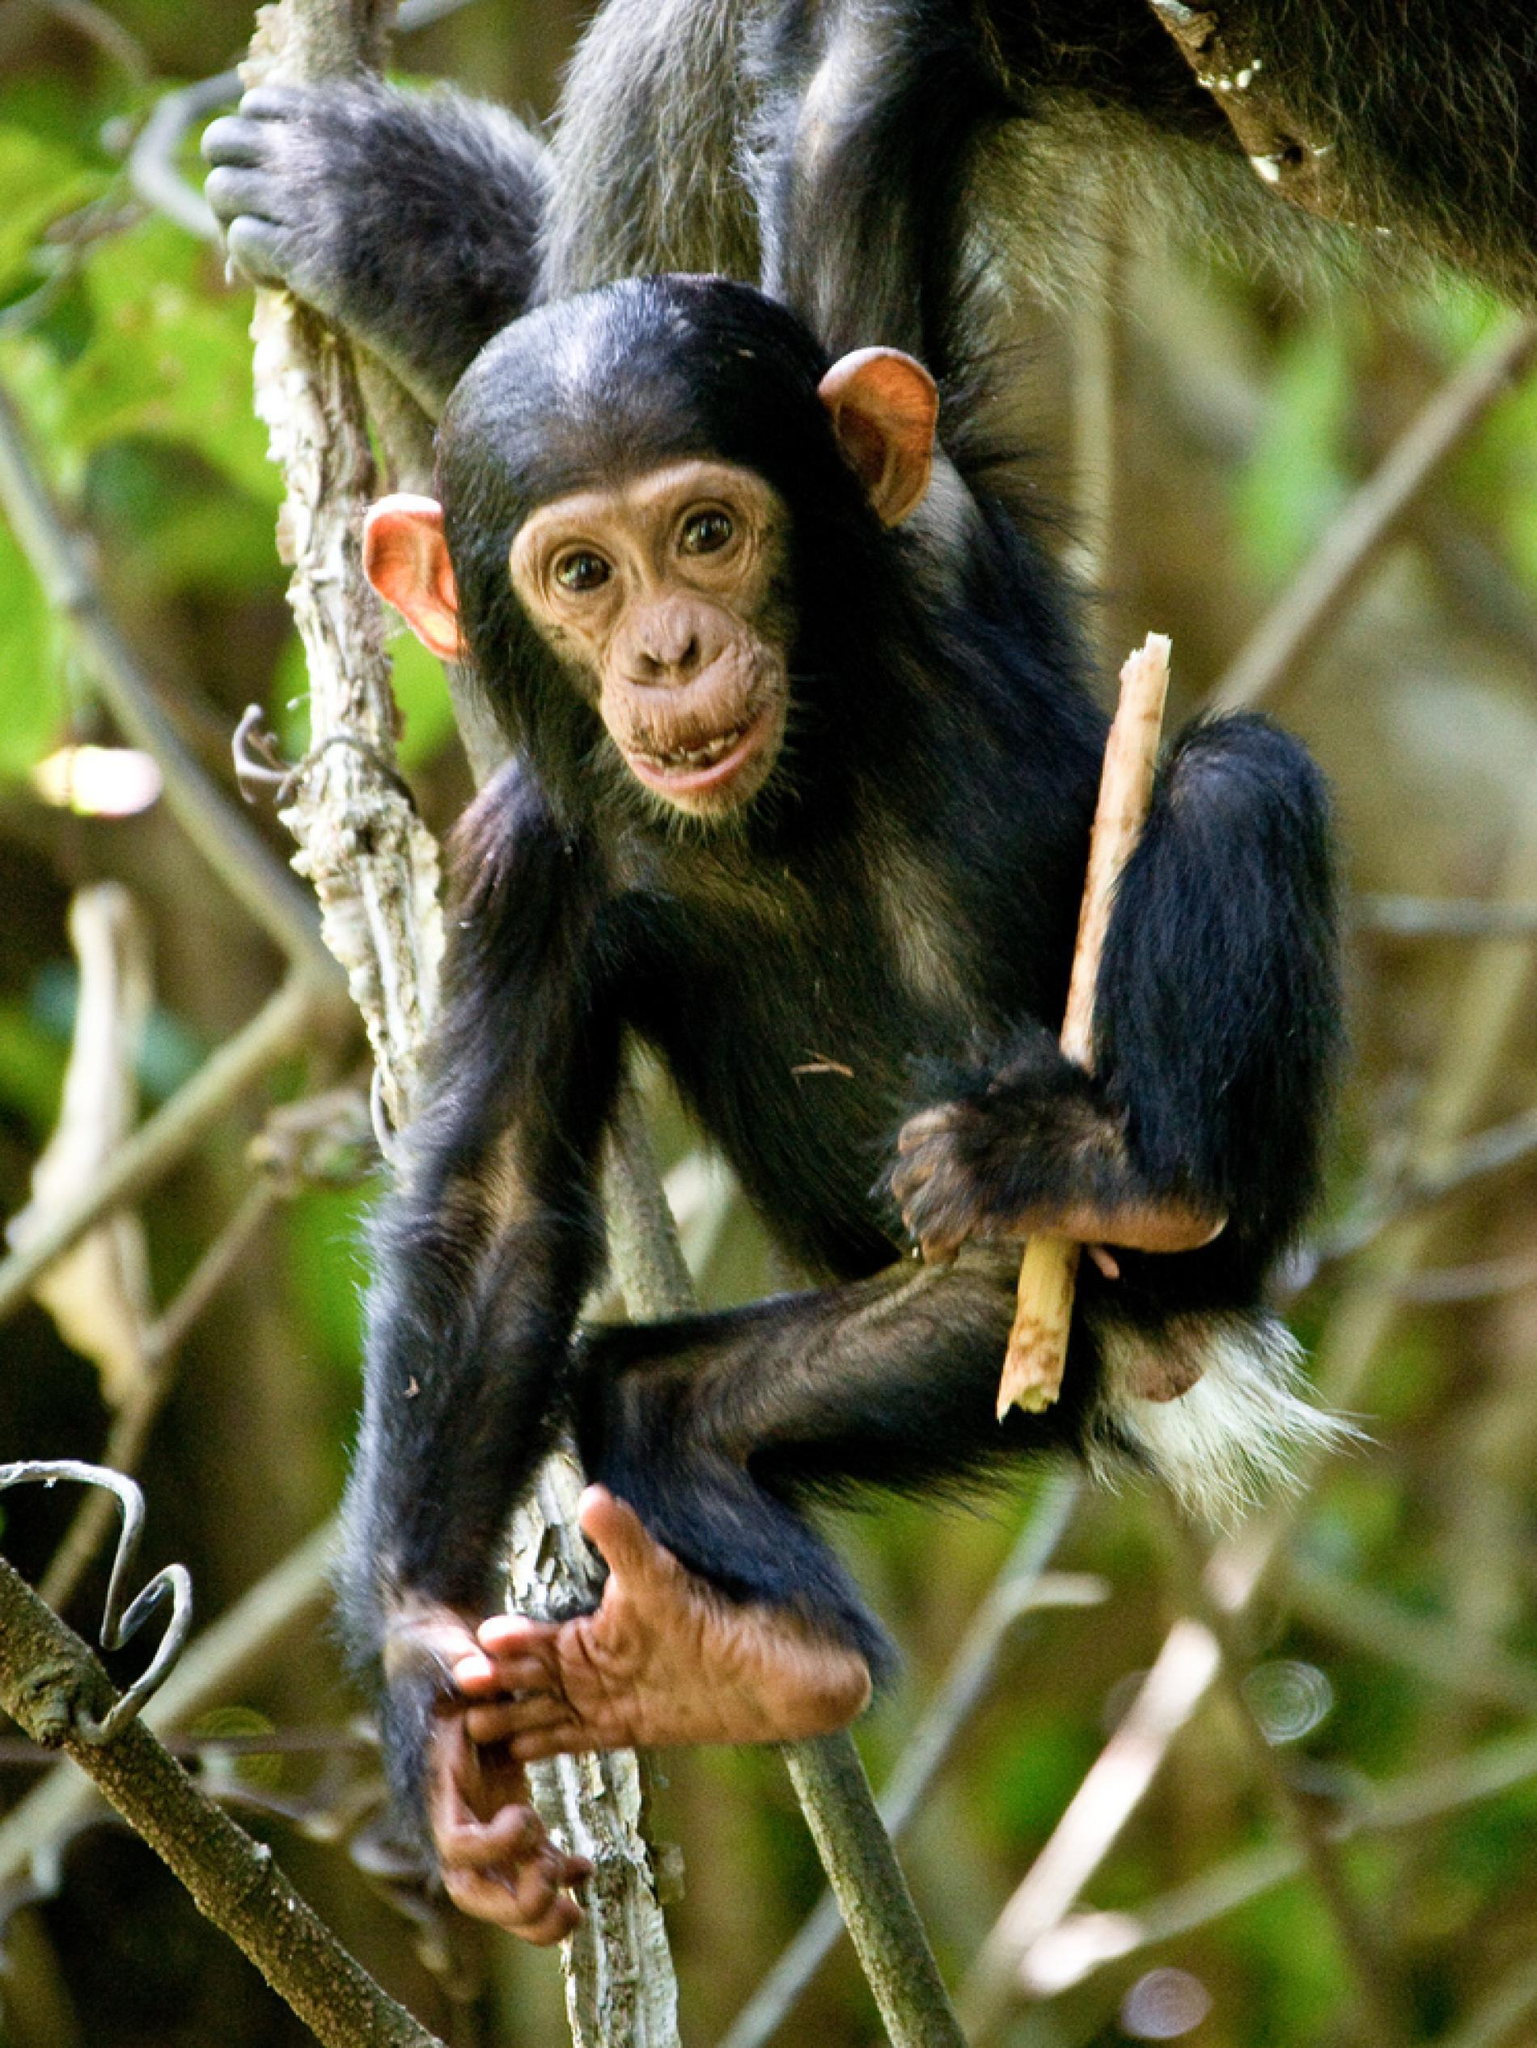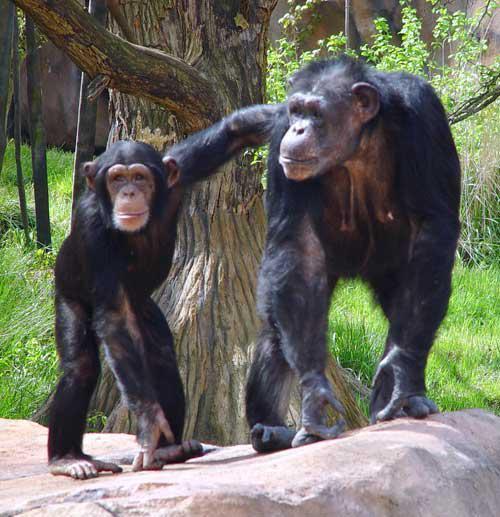The first image is the image on the left, the second image is the image on the right. Examine the images to the left and right. Is the description "The image on the right features only one chimp." accurate? Answer yes or no. No. 